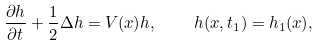<formula> <loc_0><loc_0><loc_500><loc_500>\frac { \partial h } { \partial t } + \frac { 1 } { 2 } \Delta h = V ( x ) h , \quad h ( x , t _ { 1 } ) = h _ { 1 } ( x ) ,</formula> 